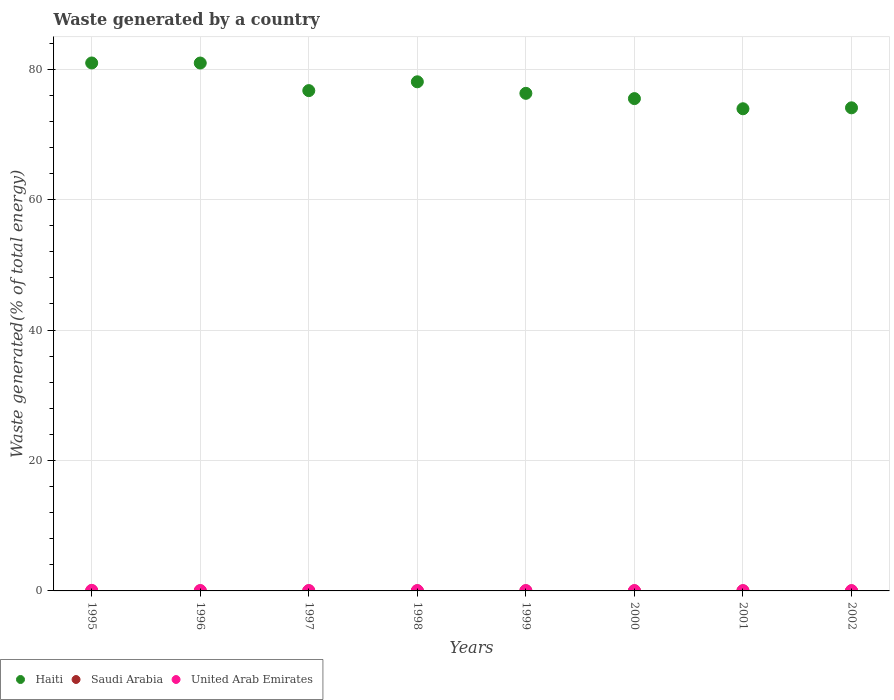How many different coloured dotlines are there?
Give a very brief answer. 3. What is the total waste generated in Saudi Arabia in 2002?
Keep it short and to the point. 0. Across all years, what is the maximum total waste generated in Saudi Arabia?
Provide a short and direct response. 0.01. Across all years, what is the minimum total waste generated in United Arab Emirates?
Ensure brevity in your answer.  0.04. In which year was the total waste generated in Saudi Arabia maximum?
Offer a very short reply. 1995. What is the total total waste generated in United Arab Emirates in the graph?
Provide a succinct answer. 0.44. What is the difference between the total waste generated in Saudi Arabia in 1999 and that in 2002?
Your answer should be compact. 0. What is the difference between the total waste generated in Haiti in 1999 and the total waste generated in Saudi Arabia in 1996?
Keep it short and to the point. 76.29. What is the average total waste generated in Saudi Arabia per year?
Ensure brevity in your answer.  0.01. In the year 1997, what is the difference between the total waste generated in Haiti and total waste generated in Saudi Arabia?
Offer a very short reply. 76.7. What is the ratio of the total waste generated in Saudi Arabia in 1995 to that in 2002?
Keep it short and to the point. 2.63. Is the total waste generated in Saudi Arabia in 2000 less than that in 2002?
Give a very brief answer. Yes. Is the difference between the total waste generated in Haiti in 1995 and 1996 greater than the difference between the total waste generated in Saudi Arabia in 1995 and 1996?
Provide a succinct answer. Yes. What is the difference between the highest and the second highest total waste generated in United Arab Emirates?
Provide a succinct answer. 0.03. What is the difference between the highest and the lowest total waste generated in Haiti?
Offer a very short reply. 7.02. Is the sum of the total waste generated in Saudi Arabia in 1996 and 2002 greater than the maximum total waste generated in United Arab Emirates across all years?
Make the answer very short. No. Does the total waste generated in Haiti monotonically increase over the years?
Your answer should be very brief. No. Is the total waste generated in Haiti strictly greater than the total waste generated in Saudi Arabia over the years?
Offer a terse response. Yes. How many dotlines are there?
Your answer should be compact. 3. Are the values on the major ticks of Y-axis written in scientific E-notation?
Your answer should be very brief. No. Does the graph contain any zero values?
Provide a succinct answer. No. How many legend labels are there?
Give a very brief answer. 3. What is the title of the graph?
Your answer should be very brief. Waste generated by a country. What is the label or title of the Y-axis?
Ensure brevity in your answer.  Waste generated(% of total energy). What is the Waste generated(% of total energy) in Haiti in 1995?
Your answer should be compact. 80.95. What is the Waste generated(% of total energy) of Saudi Arabia in 1995?
Your response must be concise. 0.01. What is the Waste generated(% of total energy) in United Arab Emirates in 1995?
Provide a short and direct response. 0.09. What is the Waste generated(% of total energy) of Haiti in 1996?
Your answer should be very brief. 80.93. What is the Waste generated(% of total energy) in Saudi Arabia in 1996?
Keep it short and to the point. 0. What is the Waste generated(% of total energy) in United Arab Emirates in 1996?
Your response must be concise. 0.06. What is the Waste generated(% of total energy) of Haiti in 1997?
Offer a terse response. 76.71. What is the Waste generated(% of total energy) of Saudi Arabia in 1997?
Provide a short and direct response. 0. What is the Waste generated(% of total energy) in United Arab Emirates in 1997?
Give a very brief answer. 0.06. What is the Waste generated(% of total energy) of Haiti in 1998?
Your answer should be compact. 78.06. What is the Waste generated(% of total energy) of Saudi Arabia in 1998?
Offer a terse response. 0. What is the Waste generated(% of total energy) of United Arab Emirates in 1998?
Give a very brief answer. 0.05. What is the Waste generated(% of total energy) of Haiti in 1999?
Your response must be concise. 76.29. What is the Waste generated(% of total energy) in Saudi Arabia in 1999?
Your answer should be compact. 0. What is the Waste generated(% of total energy) of United Arab Emirates in 1999?
Offer a terse response. 0.05. What is the Waste generated(% of total energy) in Haiti in 2000?
Provide a succinct answer. 75.48. What is the Waste generated(% of total energy) of Saudi Arabia in 2000?
Ensure brevity in your answer.  0. What is the Waste generated(% of total energy) in United Arab Emirates in 2000?
Your answer should be compact. 0.05. What is the Waste generated(% of total energy) in Haiti in 2001?
Your response must be concise. 73.93. What is the Waste generated(% of total energy) of Saudi Arabia in 2001?
Your answer should be very brief. 0.01. What is the Waste generated(% of total energy) in United Arab Emirates in 2001?
Provide a short and direct response. 0.05. What is the Waste generated(% of total energy) of Haiti in 2002?
Your answer should be very brief. 74.07. What is the Waste generated(% of total energy) in Saudi Arabia in 2002?
Your answer should be very brief. 0. What is the Waste generated(% of total energy) of United Arab Emirates in 2002?
Offer a very short reply. 0.04. Across all years, what is the maximum Waste generated(% of total energy) of Haiti?
Your answer should be compact. 80.95. Across all years, what is the maximum Waste generated(% of total energy) of Saudi Arabia?
Your response must be concise. 0.01. Across all years, what is the maximum Waste generated(% of total energy) of United Arab Emirates?
Your response must be concise. 0.09. Across all years, what is the minimum Waste generated(% of total energy) of Haiti?
Make the answer very short. 73.93. Across all years, what is the minimum Waste generated(% of total energy) in Saudi Arabia?
Give a very brief answer. 0. Across all years, what is the minimum Waste generated(% of total energy) of United Arab Emirates?
Give a very brief answer. 0.04. What is the total Waste generated(% of total energy) of Haiti in the graph?
Ensure brevity in your answer.  616.41. What is the total Waste generated(% of total energy) in Saudi Arabia in the graph?
Your answer should be very brief. 0.05. What is the total Waste generated(% of total energy) in United Arab Emirates in the graph?
Make the answer very short. 0.44. What is the difference between the Waste generated(% of total energy) of Haiti in 1995 and that in 1996?
Your answer should be compact. 0.01. What is the difference between the Waste generated(% of total energy) in Saudi Arabia in 1995 and that in 1996?
Provide a succinct answer. 0.01. What is the difference between the Waste generated(% of total energy) in United Arab Emirates in 1995 and that in 1996?
Offer a very short reply. 0.03. What is the difference between the Waste generated(% of total energy) of Haiti in 1995 and that in 1997?
Your answer should be compact. 4.24. What is the difference between the Waste generated(% of total energy) in Saudi Arabia in 1995 and that in 1997?
Make the answer very short. 0.01. What is the difference between the Waste generated(% of total energy) in United Arab Emirates in 1995 and that in 1997?
Offer a terse response. 0.03. What is the difference between the Waste generated(% of total energy) of Haiti in 1995 and that in 1998?
Offer a terse response. 2.89. What is the difference between the Waste generated(% of total energy) of Saudi Arabia in 1995 and that in 1998?
Your answer should be compact. 0.01. What is the difference between the Waste generated(% of total energy) in United Arab Emirates in 1995 and that in 1998?
Provide a succinct answer. 0.03. What is the difference between the Waste generated(% of total energy) in Haiti in 1995 and that in 1999?
Offer a terse response. 4.65. What is the difference between the Waste generated(% of total energy) of Saudi Arabia in 1995 and that in 1999?
Your answer should be very brief. 0.01. What is the difference between the Waste generated(% of total energy) of United Arab Emirates in 1995 and that in 1999?
Ensure brevity in your answer.  0.03. What is the difference between the Waste generated(% of total energy) of Haiti in 1995 and that in 2000?
Provide a short and direct response. 5.46. What is the difference between the Waste generated(% of total energy) in Saudi Arabia in 1995 and that in 2000?
Your response must be concise. 0.01. What is the difference between the Waste generated(% of total energy) of United Arab Emirates in 1995 and that in 2000?
Ensure brevity in your answer.  0.04. What is the difference between the Waste generated(% of total energy) of Haiti in 1995 and that in 2001?
Give a very brief answer. 7.02. What is the difference between the Waste generated(% of total energy) of Saudi Arabia in 1995 and that in 2001?
Keep it short and to the point. 0.01. What is the difference between the Waste generated(% of total energy) in United Arab Emirates in 1995 and that in 2001?
Offer a very short reply. 0.04. What is the difference between the Waste generated(% of total energy) in Haiti in 1995 and that in 2002?
Provide a short and direct response. 6.88. What is the difference between the Waste generated(% of total energy) of Saudi Arabia in 1995 and that in 2002?
Keep it short and to the point. 0.01. What is the difference between the Waste generated(% of total energy) of United Arab Emirates in 1995 and that in 2002?
Offer a terse response. 0.04. What is the difference between the Waste generated(% of total energy) in Haiti in 1996 and that in 1997?
Your answer should be compact. 4.23. What is the difference between the Waste generated(% of total energy) in Saudi Arabia in 1996 and that in 1997?
Make the answer very short. 0. What is the difference between the Waste generated(% of total energy) in United Arab Emirates in 1996 and that in 1997?
Provide a succinct answer. -0. What is the difference between the Waste generated(% of total energy) of Haiti in 1996 and that in 1998?
Give a very brief answer. 2.88. What is the difference between the Waste generated(% of total energy) of Saudi Arabia in 1996 and that in 1998?
Give a very brief answer. -0. What is the difference between the Waste generated(% of total energy) of United Arab Emirates in 1996 and that in 1998?
Ensure brevity in your answer.  0. What is the difference between the Waste generated(% of total energy) of Haiti in 1996 and that in 1999?
Provide a succinct answer. 4.64. What is the difference between the Waste generated(% of total energy) of Saudi Arabia in 1996 and that in 1999?
Make the answer very short. -0. What is the difference between the Waste generated(% of total energy) in United Arab Emirates in 1996 and that in 1999?
Give a very brief answer. 0. What is the difference between the Waste generated(% of total energy) in Haiti in 1996 and that in 2000?
Offer a terse response. 5.45. What is the difference between the Waste generated(% of total energy) in Saudi Arabia in 1996 and that in 2000?
Keep it short and to the point. 0. What is the difference between the Waste generated(% of total energy) in United Arab Emirates in 1996 and that in 2000?
Ensure brevity in your answer.  0.01. What is the difference between the Waste generated(% of total energy) in Haiti in 1996 and that in 2001?
Ensure brevity in your answer.  7.01. What is the difference between the Waste generated(% of total energy) of Saudi Arabia in 1996 and that in 2001?
Make the answer very short. -0. What is the difference between the Waste generated(% of total energy) of United Arab Emirates in 1996 and that in 2001?
Ensure brevity in your answer.  0.01. What is the difference between the Waste generated(% of total energy) of Haiti in 1996 and that in 2002?
Give a very brief answer. 6.87. What is the difference between the Waste generated(% of total energy) of Saudi Arabia in 1996 and that in 2002?
Give a very brief answer. -0. What is the difference between the Waste generated(% of total energy) of United Arab Emirates in 1996 and that in 2002?
Your response must be concise. 0.01. What is the difference between the Waste generated(% of total energy) in Haiti in 1997 and that in 1998?
Keep it short and to the point. -1.35. What is the difference between the Waste generated(% of total energy) of Saudi Arabia in 1997 and that in 1998?
Your answer should be very brief. -0. What is the difference between the Waste generated(% of total energy) of United Arab Emirates in 1997 and that in 1998?
Make the answer very short. 0. What is the difference between the Waste generated(% of total energy) of Haiti in 1997 and that in 1999?
Offer a very short reply. 0.42. What is the difference between the Waste generated(% of total energy) in Saudi Arabia in 1997 and that in 1999?
Offer a terse response. -0. What is the difference between the Waste generated(% of total energy) in United Arab Emirates in 1997 and that in 1999?
Make the answer very short. 0.01. What is the difference between the Waste generated(% of total energy) of Haiti in 1997 and that in 2000?
Your answer should be compact. 1.23. What is the difference between the Waste generated(% of total energy) in Saudi Arabia in 1997 and that in 2000?
Offer a terse response. -0. What is the difference between the Waste generated(% of total energy) in United Arab Emirates in 1997 and that in 2000?
Provide a succinct answer. 0.01. What is the difference between the Waste generated(% of total energy) of Haiti in 1997 and that in 2001?
Keep it short and to the point. 2.78. What is the difference between the Waste generated(% of total energy) in Saudi Arabia in 1997 and that in 2001?
Your answer should be very brief. -0. What is the difference between the Waste generated(% of total energy) of United Arab Emirates in 1997 and that in 2001?
Provide a succinct answer. 0.01. What is the difference between the Waste generated(% of total energy) in Haiti in 1997 and that in 2002?
Your response must be concise. 2.64. What is the difference between the Waste generated(% of total energy) in Saudi Arabia in 1997 and that in 2002?
Give a very brief answer. -0. What is the difference between the Waste generated(% of total energy) in United Arab Emirates in 1997 and that in 2002?
Provide a succinct answer. 0.02. What is the difference between the Waste generated(% of total energy) in Haiti in 1998 and that in 1999?
Your answer should be compact. 1.77. What is the difference between the Waste generated(% of total energy) in Saudi Arabia in 1998 and that in 1999?
Provide a succinct answer. 0. What is the difference between the Waste generated(% of total energy) in United Arab Emirates in 1998 and that in 1999?
Ensure brevity in your answer.  0. What is the difference between the Waste generated(% of total energy) in Haiti in 1998 and that in 2000?
Ensure brevity in your answer.  2.58. What is the difference between the Waste generated(% of total energy) in United Arab Emirates in 1998 and that in 2000?
Provide a short and direct response. 0. What is the difference between the Waste generated(% of total energy) of Haiti in 1998 and that in 2001?
Provide a succinct answer. 4.13. What is the difference between the Waste generated(% of total energy) in Saudi Arabia in 1998 and that in 2001?
Your answer should be compact. -0. What is the difference between the Waste generated(% of total energy) of United Arab Emirates in 1998 and that in 2001?
Give a very brief answer. 0.01. What is the difference between the Waste generated(% of total energy) in Haiti in 1998 and that in 2002?
Your response must be concise. 3.99. What is the difference between the Waste generated(% of total energy) in United Arab Emirates in 1998 and that in 2002?
Your response must be concise. 0.01. What is the difference between the Waste generated(% of total energy) in Haiti in 1999 and that in 2000?
Provide a short and direct response. 0.81. What is the difference between the Waste generated(% of total energy) of United Arab Emirates in 1999 and that in 2000?
Give a very brief answer. 0. What is the difference between the Waste generated(% of total energy) of Haiti in 1999 and that in 2001?
Provide a short and direct response. 2.36. What is the difference between the Waste generated(% of total energy) of Saudi Arabia in 1999 and that in 2001?
Provide a short and direct response. -0. What is the difference between the Waste generated(% of total energy) in United Arab Emirates in 1999 and that in 2001?
Offer a very short reply. 0.01. What is the difference between the Waste generated(% of total energy) of Haiti in 1999 and that in 2002?
Give a very brief answer. 2.22. What is the difference between the Waste generated(% of total energy) in Saudi Arabia in 1999 and that in 2002?
Offer a very short reply. 0. What is the difference between the Waste generated(% of total energy) of United Arab Emirates in 1999 and that in 2002?
Make the answer very short. 0.01. What is the difference between the Waste generated(% of total energy) of Haiti in 2000 and that in 2001?
Your response must be concise. 1.56. What is the difference between the Waste generated(% of total energy) in Saudi Arabia in 2000 and that in 2001?
Your answer should be very brief. -0. What is the difference between the Waste generated(% of total energy) of United Arab Emirates in 2000 and that in 2001?
Provide a short and direct response. 0. What is the difference between the Waste generated(% of total energy) in Haiti in 2000 and that in 2002?
Your answer should be compact. 1.41. What is the difference between the Waste generated(% of total energy) of Saudi Arabia in 2000 and that in 2002?
Give a very brief answer. -0. What is the difference between the Waste generated(% of total energy) in United Arab Emirates in 2000 and that in 2002?
Your answer should be compact. 0.01. What is the difference between the Waste generated(% of total energy) of Haiti in 2001 and that in 2002?
Offer a terse response. -0.14. What is the difference between the Waste generated(% of total energy) of United Arab Emirates in 2001 and that in 2002?
Your answer should be very brief. 0. What is the difference between the Waste generated(% of total energy) of Haiti in 1995 and the Waste generated(% of total energy) of Saudi Arabia in 1996?
Make the answer very short. 80.94. What is the difference between the Waste generated(% of total energy) in Haiti in 1995 and the Waste generated(% of total energy) in United Arab Emirates in 1996?
Offer a terse response. 80.89. What is the difference between the Waste generated(% of total energy) of Saudi Arabia in 1995 and the Waste generated(% of total energy) of United Arab Emirates in 1996?
Your answer should be very brief. -0.04. What is the difference between the Waste generated(% of total energy) of Haiti in 1995 and the Waste generated(% of total energy) of Saudi Arabia in 1997?
Make the answer very short. 80.94. What is the difference between the Waste generated(% of total energy) in Haiti in 1995 and the Waste generated(% of total energy) in United Arab Emirates in 1997?
Your answer should be very brief. 80.89. What is the difference between the Waste generated(% of total energy) of Saudi Arabia in 1995 and the Waste generated(% of total energy) of United Arab Emirates in 1997?
Your answer should be compact. -0.04. What is the difference between the Waste generated(% of total energy) of Haiti in 1995 and the Waste generated(% of total energy) of Saudi Arabia in 1998?
Ensure brevity in your answer.  80.94. What is the difference between the Waste generated(% of total energy) of Haiti in 1995 and the Waste generated(% of total energy) of United Arab Emirates in 1998?
Keep it short and to the point. 80.89. What is the difference between the Waste generated(% of total energy) in Saudi Arabia in 1995 and the Waste generated(% of total energy) in United Arab Emirates in 1998?
Make the answer very short. -0.04. What is the difference between the Waste generated(% of total energy) of Haiti in 1995 and the Waste generated(% of total energy) of Saudi Arabia in 1999?
Ensure brevity in your answer.  80.94. What is the difference between the Waste generated(% of total energy) in Haiti in 1995 and the Waste generated(% of total energy) in United Arab Emirates in 1999?
Provide a succinct answer. 80.89. What is the difference between the Waste generated(% of total energy) of Saudi Arabia in 1995 and the Waste generated(% of total energy) of United Arab Emirates in 1999?
Provide a short and direct response. -0.04. What is the difference between the Waste generated(% of total energy) of Haiti in 1995 and the Waste generated(% of total energy) of Saudi Arabia in 2000?
Your answer should be very brief. 80.94. What is the difference between the Waste generated(% of total energy) in Haiti in 1995 and the Waste generated(% of total energy) in United Arab Emirates in 2000?
Make the answer very short. 80.9. What is the difference between the Waste generated(% of total energy) of Saudi Arabia in 1995 and the Waste generated(% of total energy) of United Arab Emirates in 2000?
Offer a terse response. -0.04. What is the difference between the Waste generated(% of total energy) in Haiti in 1995 and the Waste generated(% of total energy) in Saudi Arabia in 2001?
Your answer should be very brief. 80.94. What is the difference between the Waste generated(% of total energy) in Haiti in 1995 and the Waste generated(% of total energy) in United Arab Emirates in 2001?
Offer a very short reply. 80.9. What is the difference between the Waste generated(% of total energy) of Saudi Arabia in 1995 and the Waste generated(% of total energy) of United Arab Emirates in 2001?
Give a very brief answer. -0.03. What is the difference between the Waste generated(% of total energy) of Haiti in 1995 and the Waste generated(% of total energy) of Saudi Arabia in 2002?
Offer a terse response. 80.94. What is the difference between the Waste generated(% of total energy) in Haiti in 1995 and the Waste generated(% of total energy) in United Arab Emirates in 2002?
Your answer should be compact. 80.9. What is the difference between the Waste generated(% of total energy) of Saudi Arabia in 1995 and the Waste generated(% of total energy) of United Arab Emirates in 2002?
Your response must be concise. -0.03. What is the difference between the Waste generated(% of total energy) in Haiti in 1996 and the Waste generated(% of total energy) in Saudi Arabia in 1997?
Offer a very short reply. 80.93. What is the difference between the Waste generated(% of total energy) in Haiti in 1996 and the Waste generated(% of total energy) in United Arab Emirates in 1997?
Offer a very short reply. 80.88. What is the difference between the Waste generated(% of total energy) in Saudi Arabia in 1996 and the Waste generated(% of total energy) in United Arab Emirates in 1997?
Provide a succinct answer. -0.05. What is the difference between the Waste generated(% of total energy) in Haiti in 1996 and the Waste generated(% of total energy) in Saudi Arabia in 1998?
Offer a very short reply. 80.93. What is the difference between the Waste generated(% of total energy) in Haiti in 1996 and the Waste generated(% of total energy) in United Arab Emirates in 1998?
Offer a very short reply. 80.88. What is the difference between the Waste generated(% of total energy) in Saudi Arabia in 1996 and the Waste generated(% of total energy) in United Arab Emirates in 1998?
Provide a succinct answer. -0.05. What is the difference between the Waste generated(% of total energy) in Haiti in 1996 and the Waste generated(% of total energy) in Saudi Arabia in 1999?
Offer a terse response. 80.93. What is the difference between the Waste generated(% of total energy) in Haiti in 1996 and the Waste generated(% of total energy) in United Arab Emirates in 1999?
Offer a very short reply. 80.88. What is the difference between the Waste generated(% of total energy) of Saudi Arabia in 1996 and the Waste generated(% of total energy) of United Arab Emirates in 1999?
Offer a terse response. -0.05. What is the difference between the Waste generated(% of total energy) of Haiti in 1996 and the Waste generated(% of total energy) of Saudi Arabia in 2000?
Your response must be concise. 80.93. What is the difference between the Waste generated(% of total energy) of Haiti in 1996 and the Waste generated(% of total energy) of United Arab Emirates in 2000?
Give a very brief answer. 80.89. What is the difference between the Waste generated(% of total energy) in Saudi Arabia in 1996 and the Waste generated(% of total energy) in United Arab Emirates in 2000?
Make the answer very short. -0.05. What is the difference between the Waste generated(% of total energy) of Haiti in 1996 and the Waste generated(% of total energy) of Saudi Arabia in 2001?
Offer a terse response. 80.93. What is the difference between the Waste generated(% of total energy) of Haiti in 1996 and the Waste generated(% of total energy) of United Arab Emirates in 2001?
Your response must be concise. 80.89. What is the difference between the Waste generated(% of total energy) in Saudi Arabia in 1996 and the Waste generated(% of total energy) in United Arab Emirates in 2001?
Ensure brevity in your answer.  -0.04. What is the difference between the Waste generated(% of total energy) of Haiti in 1996 and the Waste generated(% of total energy) of Saudi Arabia in 2002?
Your response must be concise. 80.93. What is the difference between the Waste generated(% of total energy) of Haiti in 1996 and the Waste generated(% of total energy) of United Arab Emirates in 2002?
Ensure brevity in your answer.  80.89. What is the difference between the Waste generated(% of total energy) of Saudi Arabia in 1996 and the Waste generated(% of total energy) of United Arab Emirates in 2002?
Provide a short and direct response. -0.04. What is the difference between the Waste generated(% of total energy) in Haiti in 1997 and the Waste generated(% of total energy) in Saudi Arabia in 1998?
Your response must be concise. 76.7. What is the difference between the Waste generated(% of total energy) in Haiti in 1997 and the Waste generated(% of total energy) in United Arab Emirates in 1998?
Offer a very short reply. 76.65. What is the difference between the Waste generated(% of total energy) in Saudi Arabia in 1997 and the Waste generated(% of total energy) in United Arab Emirates in 1998?
Offer a very short reply. -0.05. What is the difference between the Waste generated(% of total energy) of Haiti in 1997 and the Waste generated(% of total energy) of Saudi Arabia in 1999?
Your answer should be compact. 76.7. What is the difference between the Waste generated(% of total energy) in Haiti in 1997 and the Waste generated(% of total energy) in United Arab Emirates in 1999?
Offer a very short reply. 76.66. What is the difference between the Waste generated(% of total energy) of Saudi Arabia in 1997 and the Waste generated(% of total energy) of United Arab Emirates in 1999?
Offer a very short reply. -0.05. What is the difference between the Waste generated(% of total energy) in Haiti in 1997 and the Waste generated(% of total energy) in Saudi Arabia in 2000?
Offer a terse response. 76.7. What is the difference between the Waste generated(% of total energy) of Haiti in 1997 and the Waste generated(% of total energy) of United Arab Emirates in 2000?
Your answer should be compact. 76.66. What is the difference between the Waste generated(% of total energy) of Saudi Arabia in 1997 and the Waste generated(% of total energy) of United Arab Emirates in 2000?
Your answer should be very brief. -0.05. What is the difference between the Waste generated(% of total energy) of Haiti in 1997 and the Waste generated(% of total energy) of Saudi Arabia in 2001?
Provide a short and direct response. 76.7. What is the difference between the Waste generated(% of total energy) in Haiti in 1997 and the Waste generated(% of total energy) in United Arab Emirates in 2001?
Provide a succinct answer. 76.66. What is the difference between the Waste generated(% of total energy) in Saudi Arabia in 1997 and the Waste generated(% of total energy) in United Arab Emirates in 2001?
Your response must be concise. -0.04. What is the difference between the Waste generated(% of total energy) in Haiti in 1997 and the Waste generated(% of total energy) in Saudi Arabia in 2002?
Ensure brevity in your answer.  76.7. What is the difference between the Waste generated(% of total energy) in Haiti in 1997 and the Waste generated(% of total energy) in United Arab Emirates in 2002?
Provide a short and direct response. 76.67. What is the difference between the Waste generated(% of total energy) in Saudi Arabia in 1997 and the Waste generated(% of total energy) in United Arab Emirates in 2002?
Ensure brevity in your answer.  -0.04. What is the difference between the Waste generated(% of total energy) of Haiti in 1998 and the Waste generated(% of total energy) of Saudi Arabia in 1999?
Ensure brevity in your answer.  78.05. What is the difference between the Waste generated(% of total energy) of Haiti in 1998 and the Waste generated(% of total energy) of United Arab Emirates in 1999?
Your answer should be very brief. 78.01. What is the difference between the Waste generated(% of total energy) in Saudi Arabia in 1998 and the Waste generated(% of total energy) in United Arab Emirates in 1999?
Your answer should be very brief. -0.05. What is the difference between the Waste generated(% of total energy) of Haiti in 1998 and the Waste generated(% of total energy) of Saudi Arabia in 2000?
Give a very brief answer. 78.05. What is the difference between the Waste generated(% of total energy) in Haiti in 1998 and the Waste generated(% of total energy) in United Arab Emirates in 2000?
Make the answer very short. 78.01. What is the difference between the Waste generated(% of total energy) in Saudi Arabia in 1998 and the Waste generated(% of total energy) in United Arab Emirates in 2000?
Ensure brevity in your answer.  -0.04. What is the difference between the Waste generated(% of total energy) in Haiti in 1998 and the Waste generated(% of total energy) in Saudi Arabia in 2001?
Provide a succinct answer. 78.05. What is the difference between the Waste generated(% of total energy) in Haiti in 1998 and the Waste generated(% of total energy) in United Arab Emirates in 2001?
Ensure brevity in your answer.  78.01. What is the difference between the Waste generated(% of total energy) of Saudi Arabia in 1998 and the Waste generated(% of total energy) of United Arab Emirates in 2001?
Provide a short and direct response. -0.04. What is the difference between the Waste generated(% of total energy) of Haiti in 1998 and the Waste generated(% of total energy) of Saudi Arabia in 2002?
Offer a very short reply. 78.05. What is the difference between the Waste generated(% of total energy) in Haiti in 1998 and the Waste generated(% of total energy) in United Arab Emirates in 2002?
Offer a terse response. 78.02. What is the difference between the Waste generated(% of total energy) in Saudi Arabia in 1998 and the Waste generated(% of total energy) in United Arab Emirates in 2002?
Make the answer very short. -0.04. What is the difference between the Waste generated(% of total energy) of Haiti in 1999 and the Waste generated(% of total energy) of Saudi Arabia in 2000?
Make the answer very short. 76.29. What is the difference between the Waste generated(% of total energy) of Haiti in 1999 and the Waste generated(% of total energy) of United Arab Emirates in 2000?
Provide a short and direct response. 76.24. What is the difference between the Waste generated(% of total energy) in Saudi Arabia in 1999 and the Waste generated(% of total energy) in United Arab Emirates in 2000?
Make the answer very short. -0.05. What is the difference between the Waste generated(% of total energy) of Haiti in 1999 and the Waste generated(% of total energy) of Saudi Arabia in 2001?
Offer a terse response. 76.29. What is the difference between the Waste generated(% of total energy) in Haiti in 1999 and the Waste generated(% of total energy) in United Arab Emirates in 2001?
Ensure brevity in your answer.  76.25. What is the difference between the Waste generated(% of total energy) in Saudi Arabia in 1999 and the Waste generated(% of total energy) in United Arab Emirates in 2001?
Your answer should be very brief. -0.04. What is the difference between the Waste generated(% of total energy) in Haiti in 1999 and the Waste generated(% of total energy) in Saudi Arabia in 2002?
Provide a short and direct response. 76.29. What is the difference between the Waste generated(% of total energy) of Haiti in 1999 and the Waste generated(% of total energy) of United Arab Emirates in 2002?
Keep it short and to the point. 76.25. What is the difference between the Waste generated(% of total energy) of Saudi Arabia in 1999 and the Waste generated(% of total energy) of United Arab Emirates in 2002?
Offer a very short reply. -0.04. What is the difference between the Waste generated(% of total energy) in Haiti in 2000 and the Waste generated(% of total energy) in Saudi Arabia in 2001?
Your answer should be compact. 75.48. What is the difference between the Waste generated(% of total energy) in Haiti in 2000 and the Waste generated(% of total energy) in United Arab Emirates in 2001?
Ensure brevity in your answer.  75.44. What is the difference between the Waste generated(% of total energy) of Saudi Arabia in 2000 and the Waste generated(% of total energy) of United Arab Emirates in 2001?
Your answer should be very brief. -0.04. What is the difference between the Waste generated(% of total energy) of Haiti in 2000 and the Waste generated(% of total energy) of Saudi Arabia in 2002?
Your answer should be compact. 75.48. What is the difference between the Waste generated(% of total energy) in Haiti in 2000 and the Waste generated(% of total energy) in United Arab Emirates in 2002?
Provide a succinct answer. 75.44. What is the difference between the Waste generated(% of total energy) in Saudi Arabia in 2000 and the Waste generated(% of total energy) in United Arab Emirates in 2002?
Make the answer very short. -0.04. What is the difference between the Waste generated(% of total energy) of Haiti in 2001 and the Waste generated(% of total energy) of Saudi Arabia in 2002?
Your answer should be compact. 73.92. What is the difference between the Waste generated(% of total energy) in Haiti in 2001 and the Waste generated(% of total energy) in United Arab Emirates in 2002?
Your answer should be very brief. 73.88. What is the difference between the Waste generated(% of total energy) of Saudi Arabia in 2001 and the Waste generated(% of total energy) of United Arab Emirates in 2002?
Your response must be concise. -0.04. What is the average Waste generated(% of total energy) in Haiti per year?
Provide a short and direct response. 77.05. What is the average Waste generated(% of total energy) of Saudi Arabia per year?
Offer a terse response. 0.01. What is the average Waste generated(% of total energy) in United Arab Emirates per year?
Ensure brevity in your answer.  0.06. In the year 1995, what is the difference between the Waste generated(% of total energy) in Haiti and Waste generated(% of total energy) in Saudi Arabia?
Your answer should be compact. 80.93. In the year 1995, what is the difference between the Waste generated(% of total energy) in Haiti and Waste generated(% of total energy) in United Arab Emirates?
Provide a succinct answer. 80.86. In the year 1995, what is the difference between the Waste generated(% of total energy) of Saudi Arabia and Waste generated(% of total energy) of United Arab Emirates?
Provide a succinct answer. -0.07. In the year 1996, what is the difference between the Waste generated(% of total energy) of Haiti and Waste generated(% of total energy) of Saudi Arabia?
Your answer should be compact. 80.93. In the year 1996, what is the difference between the Waste generated(% of total energy) of Haiti and Waste generated(% of total energy) of United Arab Emirates?
Make the answer very short. 80.88. In the year 1996, what is the difference between the Waste generated(% of total energy) of Saudi Arabia and Waste generated(% of total energy) of United Arab Emirates?
Make the answer very short. -0.05. In the year 1997, what is the difference between the Waste generated(% of total energy) in Haiti and Waste generated(% of total energy) in Saudi Arabia?
Keep it short and to the point. 76.7. In the year 1997, what is the difference between the Waste generated(% of total energy) in Haiti and Waste generated(% of total energy) in United Arab Emirates?
Your response must be concise. 76.65. In the year 1997, what is the difference between the Waste generated(% of total energy) in Saudi Arabia and Waste generated(% of total energy) in United Arab Emirates?
Your answer should be compact. -0.05. In the year 1998, what is the difference between the Waste generated(% of total energy) of Haiti and Waste generated(% of total energy) of Saudi Arabia?
Your answer should be very brief. 78.05. In the year 1998, what is the difference between the Waste generated(% of total energy) of Haiti and Waste generated(% of total energy) of United Arab Emirates?
Provide a succinct answer. 78.01. In the year 1998, what is the difference between the Waste generated(% of total energy) in Saudi Arabia and Waste generated(% of total energy) in United Arab Emirates?
Offer a terse response. -0.05. In the year 1999, what is the difference between the Waste generated(% of total energy) of Haiti and Waste generated(% of total energy) of Saudi Arabia?
Provide a succinct answer. 76.29. In the year 1999, what is the difference between the Waste generated(% of total energy) in Haiti and Waste generated(% of total energy) in United Arab Emirates?
Your answer should be very brief. 76.24. In the year 1999, what is the difference between the Waste generated(% of total energy) in Saudi Arabia and Waste generated(% of total energy) in United Arab Emirates?
Offer a very short reply. -0.05. In the year 2000, what is the difference between the Waste generated(% of total energy) of Haiti and Waste generated(% of total energy) of Saudi Arabia?
Your answer should be very brief. 75.48. In the year 2000, what is the difference between the Waste generated(% of total energy) of Haiti and Waste generated(% of total energy) of United Arab Emirates?
Your response must be concise. 75.43. In the year 2000, what is the difference between the Waste generated(% of total energy) in Saudi Arabia and Waste generated(% of total energy) in United Arab Emirates?
Provide a short and direct response. -0.05. In the year 2001, what is the difference between the Waste generated(% of total energy) of Haiti and Waste generated(% of total energy) of Saudi Arabia?
Keep it short and to the point. 73.92. In the year 2001, what is the difference between the Waste generated(% of total energy) of Haiti and Waste generated(% of total energy) of United Arab Emirates?
Make the answer very short. 73.88. In the year 2001, what is the difference between the Waste generated(% of total energy) in Saudi Arabia and Waste generated(% of total energy) in United Arab Emirates?
Your answer should be compact. -0.04. In the year 2002, what is the difference between the Waste generated(% of total energy) in Haiti and Waste generated(% of total energy) in Saudi Arabia?
Give a very brief answer. 74.06. In the year 2002, what is the difference between the Waste generated(% of total energy) in Haiti and Waste generated(% of total energy) in United Arab Emirates?
Ensure brevity in your answer.  74.03. In the year 2002, what is the difference between the Waste generated(% of total energy) of Saudi Arabia and Waste generated(% of total energy) of United Arab Emirates?
Keep it short and to the point. -0.04. What is the ratio of the Waste generated(% of total energy) of Saudi Arabia in 1995 to that in 1996?
Give a very brief answer. 2.66. What is the ratio of the Waste generated(% of total energy) of United Arab Emirates in 1995 to that in 1996?
Give a very brief answer. 1.51. What is the ratio of the Waste generated(% of total energy) in Haiti in 1995 to that in 1997?
Make the answer very short. 1.06. What is the ratio of the Waste generated(% of total energy) in Saudi Arabia in 1995 to that in 1997?
Provide a succinct answer. 2.75. What is the ratio of the Waste generated(% of total energy) of United Arab Emirates in 1995 to that in 1997?
Offer a terse response. 1.49. What is the ratio of the Waste generated(% of total energy) in Haiti in 1995 to that in 1998?
Keep it short and to the point. 1.04. What is the ratio of the Waste generated(% of total energy) in Saudi Arabia in 1995 to that in 1998?
Provide a succinct answer. 2.53. What is the ratio of the Waste generated(% of total energy) of United Arab Emirates in 1995 to that in 1998?
Keep it short and to the point. 1.61. What is the ratio of the Waste generated(% of total energy) of Haiti in 1995 to that in 1999?
Your response must be concise. 1.06. What is the ratio of the Waste generated(% of total energy) in Saudi Arabia in 1995 to that in 1999?
Keep it short and to the point. 2.58. What is the ratio of the Waste generated(% of total energy) in United Arab Emirates in 1995 to that in 1999?
Your answer should be very brief. 1.64. What is the ratio of the Waste generated(% of total energy) in Haiti in 1995 to that in 2000?
Your response must be concise. 1.07. What is the ratio of the Waste generated(% of total energy) in Saudi Arabia in 1995 to that in 2000?
Your answer should be compact. 2.7. What is the ratio of the Waste generated(% of total energy) in United Arab Emirates in 1995 to that in 2000?
Keep it short and to the point. 1.71. What is the ratio of the Waste generated(% of total energy) in Haiti in 1995 to that in 2001?
Your answer should be compact. 1.09. What is the ratio of the Waste generated(% of total energy) in Saudi Arabia in 1995 to that in 2001?
Keep it short and to the point. 2.38. What is the ratio of the Waste generated(% of total energy) of United Arab Emirates in 1995 to that in 2001?
Your answer should be compact. 1.88. What is the ratio of the Waste generated(% of total energy) in Haiti in 1995 to that in 2002?
Make the answer very short. 1.09. What is the ratio of the Waste generated(% of total energy) of Saudi Arabia in 1995 to that in 2002?
Offer a very short reply. 2.63. What is the ratio of the Waste generated(% of total energy) in United Arab Emirates in 1995 to that in 2002?
Offer a terse response. 2.04. What is the ratio of the Waste generated(% of total energy) in Haiti in 1996 to that in 1997?
Ensure brevity in your answer.  1.06. What is the ratio of the Waste generated(% of total energy) in Saudi Arabia in 1996 to that in 1997?
Ensure brevity in your answer.  1.04. What is the ratio of the Waste generated(% of total energy) in United Arab Emirates in 1996 to that in 1997?
Make the answer very short. 0.99. What is the ratio of the Waste generated(% of total energy) of Haiti in 1996 to that in 1998?
Provide a succinct answer. 1.04. What is the ratio of the Waste generated(% of total energy) of Saudi Arabia in 1996 to that in 1998?
Make the answer very short. 0.95. What is the ratio of the Waste generated(% of total energy) of United Arab Emirates in 1996 to that in 1998?
Keep it short and to the point. 1.07. What is the ratio of the Waste generated(% of total energy) of Haiti in 1996 to that in 1999?
Give a very brief answer. 1.06. What is the ratio of the Waste generated(% of total energy) in Saudi Arabia in 1996 to that in 1999?
Give a very brief answer. 0.97. What is the ratio of the Waste generated(% of total energy) in United Arab Emirates in 1996 to that in 1999?
Keep it short and to the point. 1.09. What is the ratio of the Waste generated(% of total energy) of Haiti in 1996 to that in 2000?
Offer a very short reply. 1.07. What is the ratio of the Waste generated(% of total energy) of Saudi Arabia in 1996 to that in 2000?
Your answer should be compact. 1.01. What is the ratio of the Waste generated(% of total energy) in United Arab Emirates in 1996 to that in 2000?
Your response must be concise. 1.13. What is the ratio of the Waste generated(% of total energy) of Haiti in 1996 to that in 2001?
Offer a very short reply. 1.09. What is the ratio of the Waste generated(% of total energy) in Saudi Arabia in 1996 to that in 2001?
Provide a short and direct response. 0.89. What is the ratio of the Waste generated(% of total energy) in United Arab Emirates in 1996 to that in 2001?
Your answer should be very brief. 1.25. What is the ratio of the Waste generated(% of total energy) in Haiti in 1996 to that in 2002?
Your answer should be compact. 1.09. What is the ratio of the Waste generated(% of total energy) of Saudi Arabia in 1996 to that in 2002?
Your response must be concise. 0.99. What is the ratio of the Waste generated(% of total energy) of United Arab Emirates in 1996 to that in 2002?
Ensure brevity in your answer.  1.35. What is the ratio of the Waste generated(% of total energy) in Haiti in 1997 to that in 1998?
Keep it short and to the point. 0.98. What is the ratio of the Waste generated(% of total energy) in Saudi Arabia in 1997 to that in 1998?
Make the answer very short. 0.92. What is the ratio of the Waste generated(% of total energy) in United Arab Emirates in 1997 to that in 1998?
Give a very brief answer. 1.08. What is the ratio of the Waste generated(% of total energy) in Saudi Arabia in 1997 to that in 1999?
Offer a terse response. 0.94. What is the ratio of the Waste generated(% of total energy) in United Arab Emirates in 1997 to that in 1999?
Offer a very short reply. 1.1. What is the ratio of the Waste generated(% of total energy) of Haiti in 1997 to that in 2000?
Provide a short and direct response. 1.02. What is the ratio of the Waste generated(% of total energy) in Saudi Arabia in 1997 to that in 2000?
Your answer should be compact. 0.98. What is the ratio of the Waste generated(% of total energy) of United Arab Emirates in 1997 to that in 2000?
Offer a terse response. 1.15. What is the ratio of the Waste generated(% of total energy) of Haiti in 1997 to that in 2001?
Make the answer very short. 1.04. What is the ratio of the Waste generated(% of total energy) of Saudi Arabia in 1997 to that in 2001?
Offer a very short reply. 0.86. What is the ratio of the Waste generated(% of total energy) of United Arab Emirates in 1997 to that in 2001?
Offer a terse response. 1.26. What is the ratio of the Waste generated(% of total energy) in Haiti in 1997 to that in 2002?
Keep it short and to the point. 1.04. What is the ratio of the Waste generated(% of total energy) in Saudi Arabia in 1997 to that in 2002?
Ensure brevity in your answer.  0.96. What is the ratio of the Waste generated(% of total energy) of United Arab Emirates in 1997 to that in 2002?
Your answer should be very brief. 1.37. What is the ratio of the Waste generated(% of total energy) of Haiti in 1998 to that in 1999?
Keep it short and to the point. 1.02. What is the ratio of the Waste generated(% of total energy) of Saudi Arabia in 1998 to that in 1999?
Keep it short and to the point. 1.02. What is the ratio of the Waste generated(% of total energy) in United Arab Emirates in 1998 to that in 1999?
Keep it short and to the point. 1.02. What is the ratio of the Waste generated(% of total energy) of Haiti in 1998 to that in 2000?
Your answer should be very brief. 1.03. What is the ratio of the Waste generated(% of total energy) in Saudi Arabia in 1998 to that in 2000?
Provide a short and direct response. 1.06. What is the ratio of the Waste generated(% of total energy) of United Arab Emirates in 1998 to that in 2000?
Ensure brevity in your answer.  1.06. What is the ratio of the Waste generated(% of total energy) in Haiti in 1998 to that in 2001?
Your answer should be compact. 1.06. What is the ratio of the Waste generated(% of total energy) of Saudi Arabia in 1998 to that in 2001?
Offer a terse response. 0.94. What is the ratio of the Waste generated(% of total energy) in United Arab Emirates in 1998 to that in 2001?
Offer a very short reply. 1.17. What is the ratio of the Waste generated(% of total energy) of Haiti in 1998 to that in 2002?
Keep it short and to the point. 1.05. What is the ratio of the Waste generated(% of total energy) of Saudi Arabia in 1998 to that in 2002?
Your answer should be very brief. 1.04. What is the ratio of the Waste generated(% of total energy) of United Arab Emirates in 1998 to that in 2002?
Offer a terse response. 1.27. What is the ratio of the Waste generated(% of total energy) in Haiti in 1999 to that in 2000?
Provide a succinct answer. 1.01. What is the ratio of the Waste generated(% of total energy) of Saudi Arabia in 1999 to that in 2000?
Keep it short and to the point. 1.05. What is the ratio of the Waste generated(% of total energy) in United Arab Emirates in 1999 to that in 2000?
Your response must be concise. 1.04. What is the ratio of the Waste generated(% of total energy) of Haiti in 1999 to that in 2001?
Your answer should be very brief. 1.03. What is the ratio of the Waste generated(% of total energy) in Saudi Arabia in 1999 to that in 2001?
Your answer should be compact. 0.92. What is the ratio of the Waste generated(% of total energy) of United Arab Emirates in 1999 to that in 2001?
Provide a succinct answer. 1.15. What is the ratio of the Waste generated(% of total energy) in Saudi Arabia in 1999 to that in 2002?
Keep it short and to the point. 1.02. What is the ratio of the Waste generated(% of total energy) in United Arab Emirates in 1999 to that in 2002?
Your answer should be very brief. 1.24. What is the ratio of the Waste generated(% of total energy) in Saudi Arabia in 2000 to that in 2001?
Your answer should be compact. 0.88. What is the ratio of the Waste generated(% of total energy) in United Arab Emirates in 2000 to that in 2001?
Give a very brief answer. 1.1. What is the ratio of the Waste generated(% of total energy) of Haiti in 2000 to that in 2002?
Keep it short and to the point. 1.02. What is the ratio of the Waste generated(% of total energy) in Saudi Arabia in 2000 to that in 2002?
Provide a succinct answer. 0.98. What is the ratio of the Waste generated(% of total energy) of United Arab Emirates in 2000 to that in 2002?
Keep it short and to the point. 1.2. What is the ratio of the Waste generated(% of total energy) in Haiti in 2001 to that in 2002?
Provide a succinct answer. 1. What is the ratio of the Waste generated(% of total energy) in Saudi Arabia in 2001 to that in 2002?
Provide a succinct answer. 1.11. What is the ratio of the Waste generated(% of total energy) in United Arab Emirates in 2001 to that in 2002?
Offer a terse response. 1.09. What is the difference between the highest and the second highest Waste generated(% of total energy) in Haiti?
Your answer should be very brief. 0.01. What is the difference between the highest and the second highest Waste generated(% of total energy) of Saudi Arabia?
Ensure brevity in your answer.  0.01. What is the difference between the highest and the second highest Waste generated(% of total energy) of United Arab Emirates?
Keep it short and to the point. 0.03. What is the difference between the highest and the lowest Waste generated(% of total energy) of Haiti?
Provide a short and direct response. 7.02. What is the difference between the highest and the lowest Waste generated(% of total energy) of Saudi Arabia?
Your answer should be very brief. 0.01. What is the difference between the highest and the lowest Waste generated(% of total energy) of United Arab Emirates?
Keep it short and to the point. 0.04. 